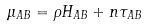<formula> <loc_0><loc_0><loc_500><loc_500>\mu _ { A B } = \rho H _ { A B } + n \tau _ { A B }</formula> 